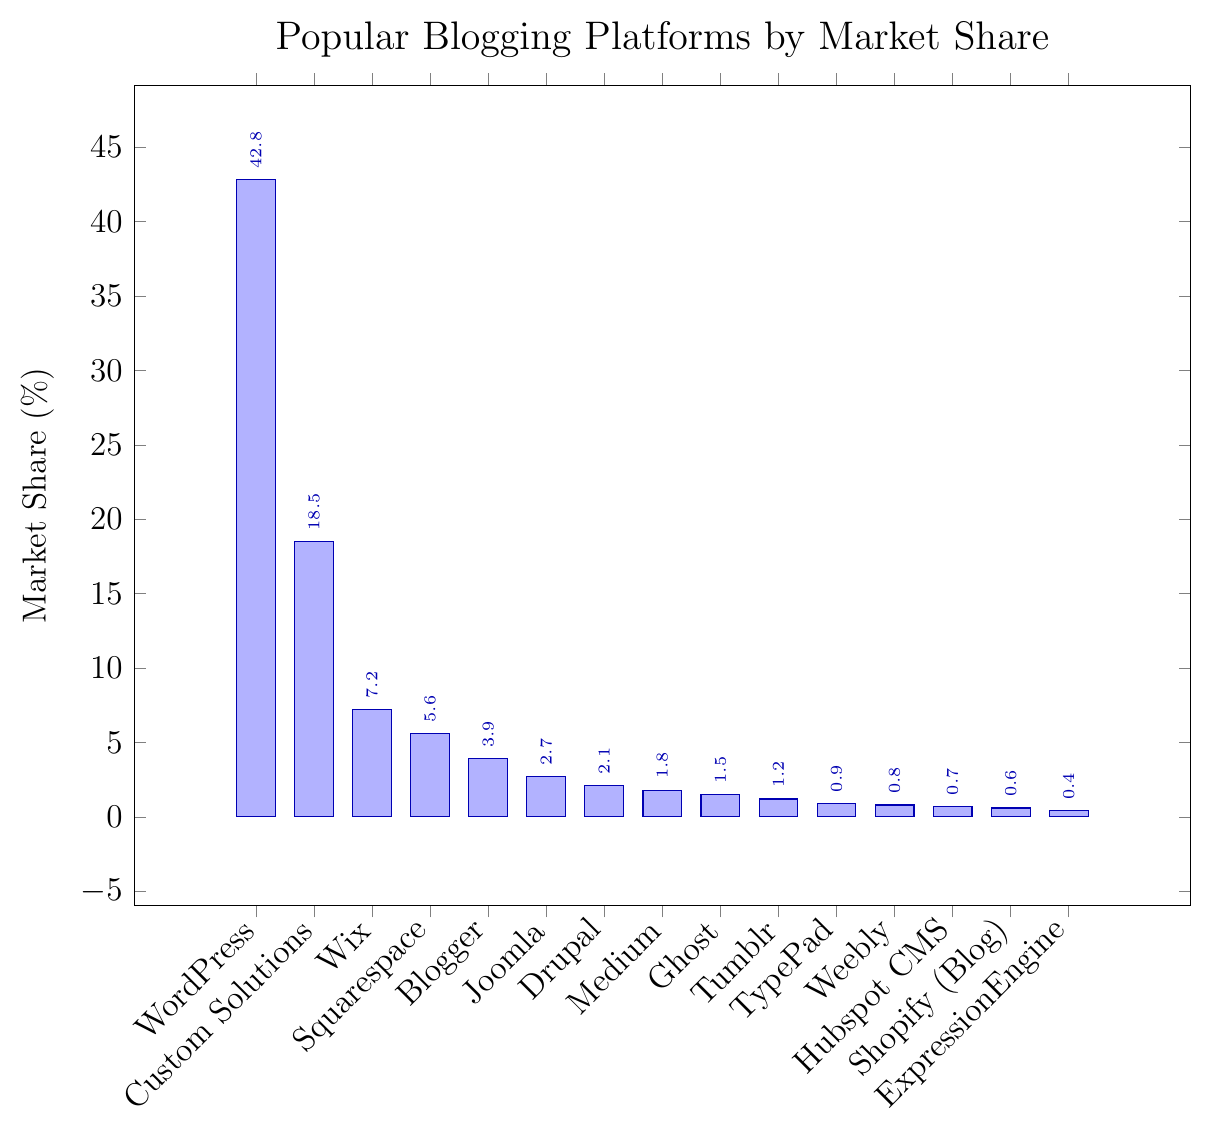What is the platform with the highest market share? From the bar chart, the highest bar represents the platform with the largest market share, which is WordPress with a 42.8% market share.
Answer: WordPress What is the difference in market share between Custom Solutions and Wix? Custom Solutions has a market share of 18.5%, and Wix has 7.2%. Subtracting Wix's percentage from Custom Solution's gives 18.5% - 7.2% = 11.3%.
Answer: 11.3% How many platforms have a market share of 1.5% or higher? The platforms with a market share of 1.5% or higher are WordPress (42.8%), Custom Solutions (18.5%), Wix (7.2%), Squarespace (5.6%), Blogger (3.9%), Joomla (2.7%), Drupal (2.1%), and Medium (1.8%). This makes eight platforms.
Answer: 8 What is the sum of the market share for Medium, Ghost, and Tumblr? The market shares are Medium (1.8%), Ghost (1.5%), and Tumblr (1.2%). Adding these together results in 1.8% + 1.5% + 1.2% = 4.5%.
Answer: 4.5% Are there more platforms with a market share above 5% or below 1%? Platforms above 5% are WordPress, Custom Solutions, Wix, and Squarespace (4 platforms). Platforms below 1% are TypePad, Weebly, Hubspot CMS, Shopify (Blog), and ExpressionEngine (5 platforms). There are more platforms below 1%.
Answer: below 1% Which platform has the closest market share to Drupal? From the chart, Medium has a market share of 1.8%, which is closest to Drupal's 2.1%. The difference is 2.1% - 1.8% = 0.3%, smaller than other differences.
Answer: Medium What are the total market shares of the top 3 platforms combined? The top 3 platforms are WordPress (42.8%), Custom Solutions (18.5%), and Wix (7.2%). Adding these together results in 42.8% + 18.5% + 7.2% = 68.5%.
Answer: 68.5% Which platform is directly ranked after Joomla by market share? Joomla has a market share of 2.7%, and the next highest after Joomla is Drupal with 2.1%.
Answer: Drupal What is the mean market share of platforms with less than 2% share? Platforms with less than 2% shares are Medium (1.8%), Ghost (1.5%), Tumblr (1.2%), TypePad (0.9%), Weebly (0.8%), Hubspot CMS (0.7%), Shopify (Blog) (0.6%), and ExpressionEngine (0.4%). Summing them gives 1.8% + 1.5% + 1.2% + 0.9% + 0.8% + 0.7% + 0.6% + 0.4% = 7.9%. The mean is 7.9% / 8 = 0.9875%.
Answer: 0.9875% Which platform's market share is visually represented by the shortest bar? ExpressionEngine has the shortest bar with a market share of 0.4%.
Answer: ExpressionEngine 